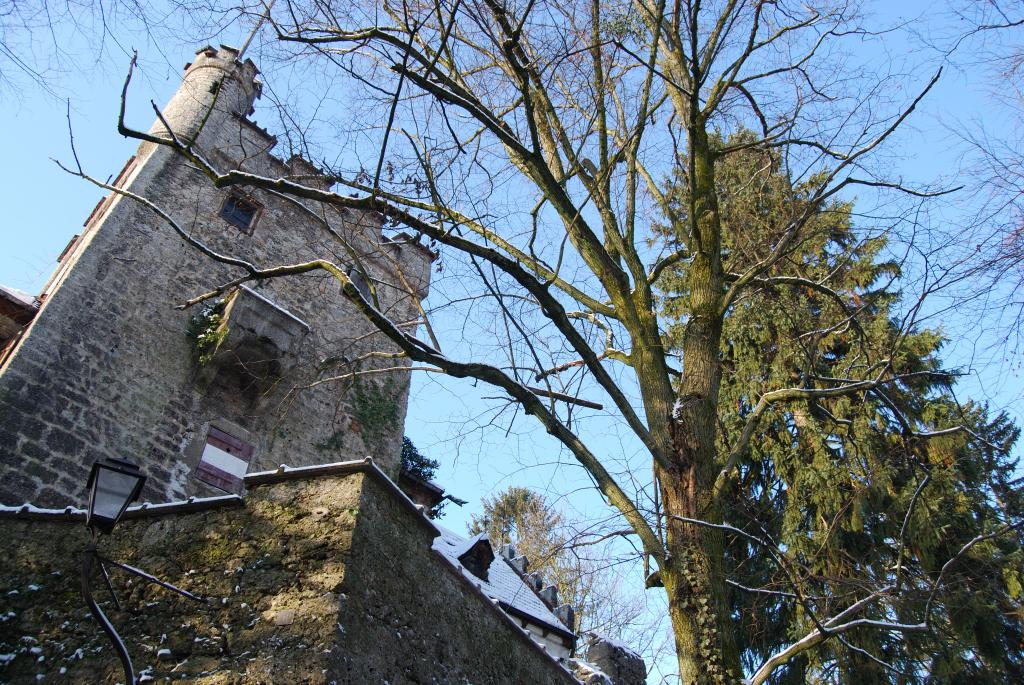What is the main structure in the image? There is a building in the image. What can be seen on the wall of the building? There are lights on the wall of the building. What type of natural elements are visible in the background of the image? There are trees in the background of the image. What part of the natural environment is visible in the image? The sky is visible in the background of the image. Where is the kettle located in the image? There is no kettle present in the image. What type of work is being done in the image? The image does not depict any work being done; it shows a building with lights on the wall and trees in the background. 